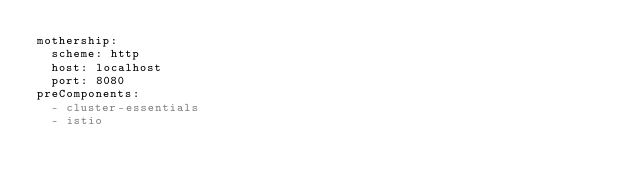Convert code to text. <code><loc_0><loc_0><loc_500><loc_500><_YAML_>mothership:
  scheme: http
  host: localhost
  port: 8080
preComponents:
  - cluster-essentials
  - istio
</code> 